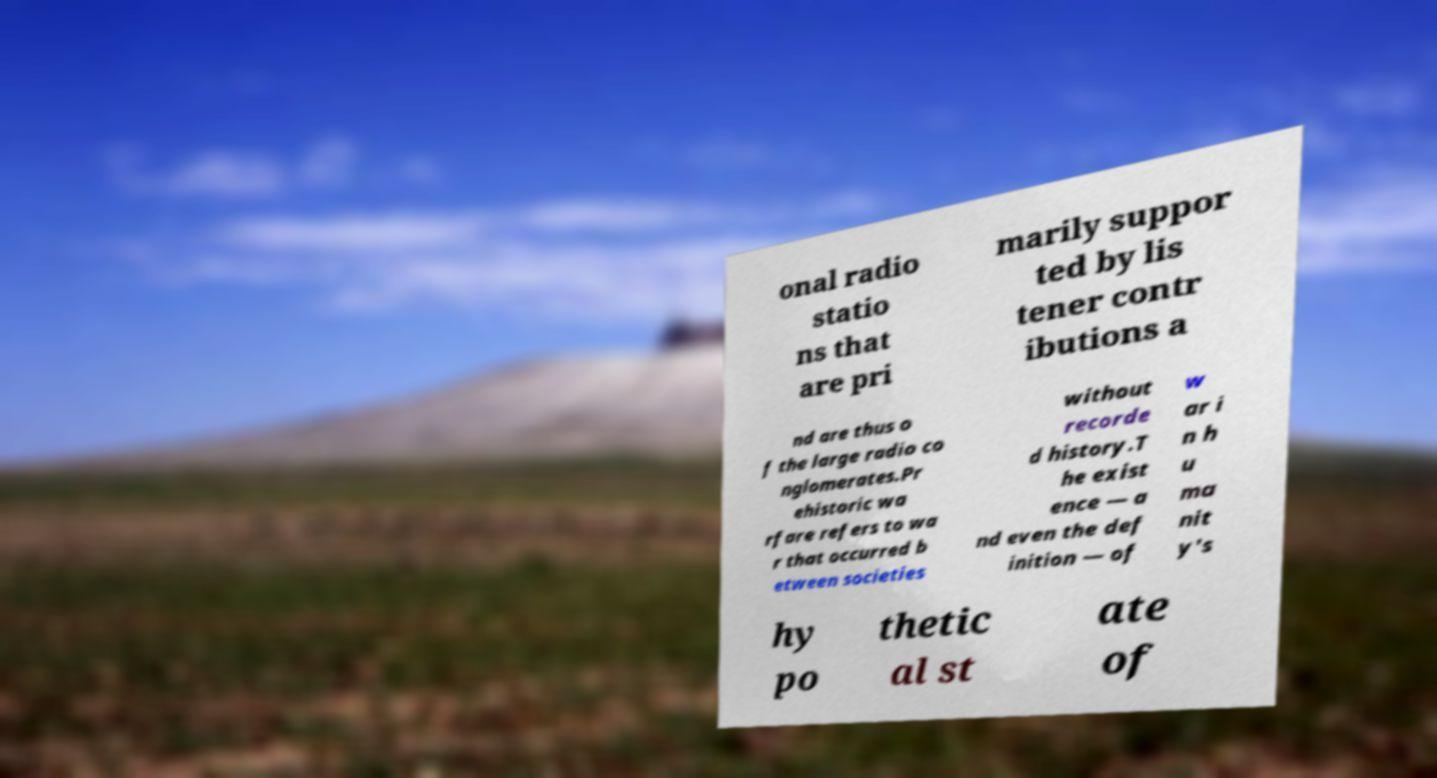Please identify and transcribe the text found in this image. onal radio statio ns that are pri marily suppor ted by lis tener contr ibutions a nd are thus o f the large radio co nglomerates.Pr ehistoric wa rfare refers to wa r that occurred b etween societies without recorde d history.T he exist ence — a nd even the def inition — of w ar i n h u ma nit y's hy po thetic al st ate of 